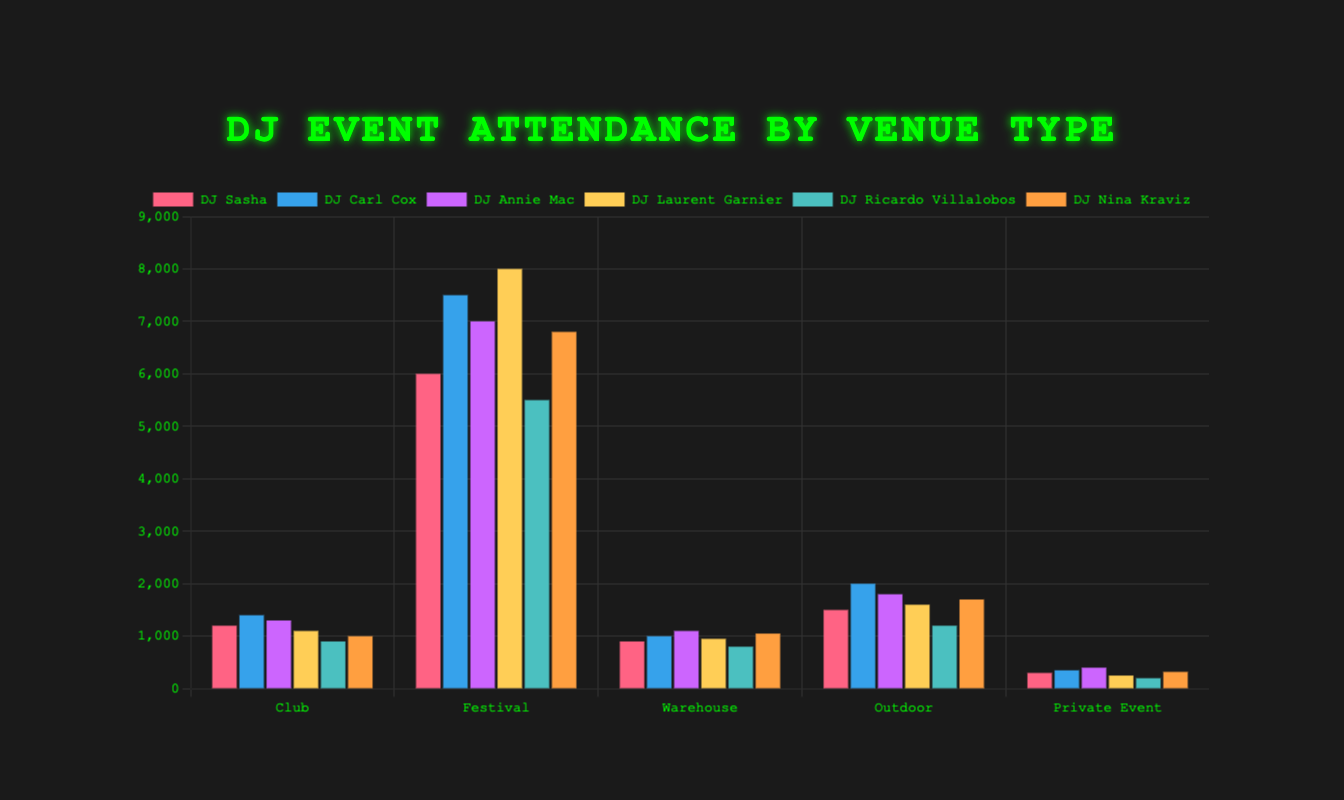Which DJ had the highest attendance at a festival? To find out which DJ had the highest attendance at a festival, look at the festival attendance bars for all DJs and find the tallest one. DJ Laurent Garnier had the highest festival attendance with 8000 attendees.
Answer: DJ Laurent Garnier Which venue type had the lowest average attendance across all DJs? To determine the venue type with the lowest average attendance, sum the attendance figures for all DJs at each venue. Divide the sum for each venue type by the number of DJs. The average attendance is the lowest for Private Event: (300 + 350 + 400 + 250 + 200 + 320) / 6 = 303.33.
Answer: Private Event Compare the attendance between DJ Carl Cox at Warehouse and Outdoor venues. Who has more attendees? To compare, look at the attendance numbers for DJ Carl Cox at Warehouse (1000) and Outdoor (2000) venues. DJ Carl Cox has more attendees at the Outdoor venue.
Answer: Outdoor What is the total attendance for DJ Sasha across all venue types? Sum the attendance numbers for DJ Sasha across all venues: 1200 (Club) + 6000 (Festival) + 900 (Warehouse) + 1500 (Outdoor) + 300 (Private Event) = 9900.
Answer: 9900 Which DJ has the least attendance in clubs? To identify the DJ with the least attendance in clubs, look at the Club attendance bars and find the shortest one. DJ Ricardo Villalobos has the least attendance in clubs with 900 attendees.
Answer: DJ Ricardo Villalobos Which DJ has the greatest difference in attendance between Club and Festival venues? Calculate the difference in attendance between Club and Festival for each DJ. DJ Laurent Garnier has: 8000 - 1100 = 6900, the greatest difference among all DJs.
Answer: DJ Laurent Garnier What is the average attendance for DJ Nina Kraviz across all venue types? Calculate the average by summing DJ Nina Kraviz's attendance across all venues and dividing by the number of venues: (1000 + 6800 + 1050 + 1700 + 320) / 5 = 2174.
Answer: 2174 How does DJ Annie Mac's attendance at Warehouses compare to DJ Nina Kraviz's attendance at Warehouses? Compare the attendance numbers: DJ Annie Mac has 1100 attendees at Warehouses, and DJ Nina Kraviz has 1050. DJ Annie Mac has more attendees at Warehouses.
Answer: DJ Annie Mac 